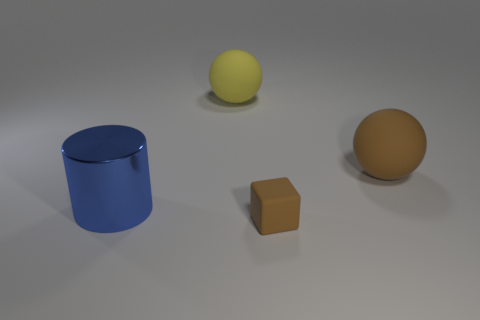Add 4 brown cubes. How many objects exist? 8 Subtract all blocks. How many objects are left? 3 Subtract all big red matte things. Subtract all yellow balls. How many objects are left? 3 Add 4 big blue metal things. How many big blue metal things are left? 5 Add 4 small yellow matte cylinders. How many small yellow matte cylinders exist? 4 Subtract 0 red cylinders. How many objects are left? 4 Subtract all red cylinders. Subtract all brown blocks. How many cylinders are left? 1 